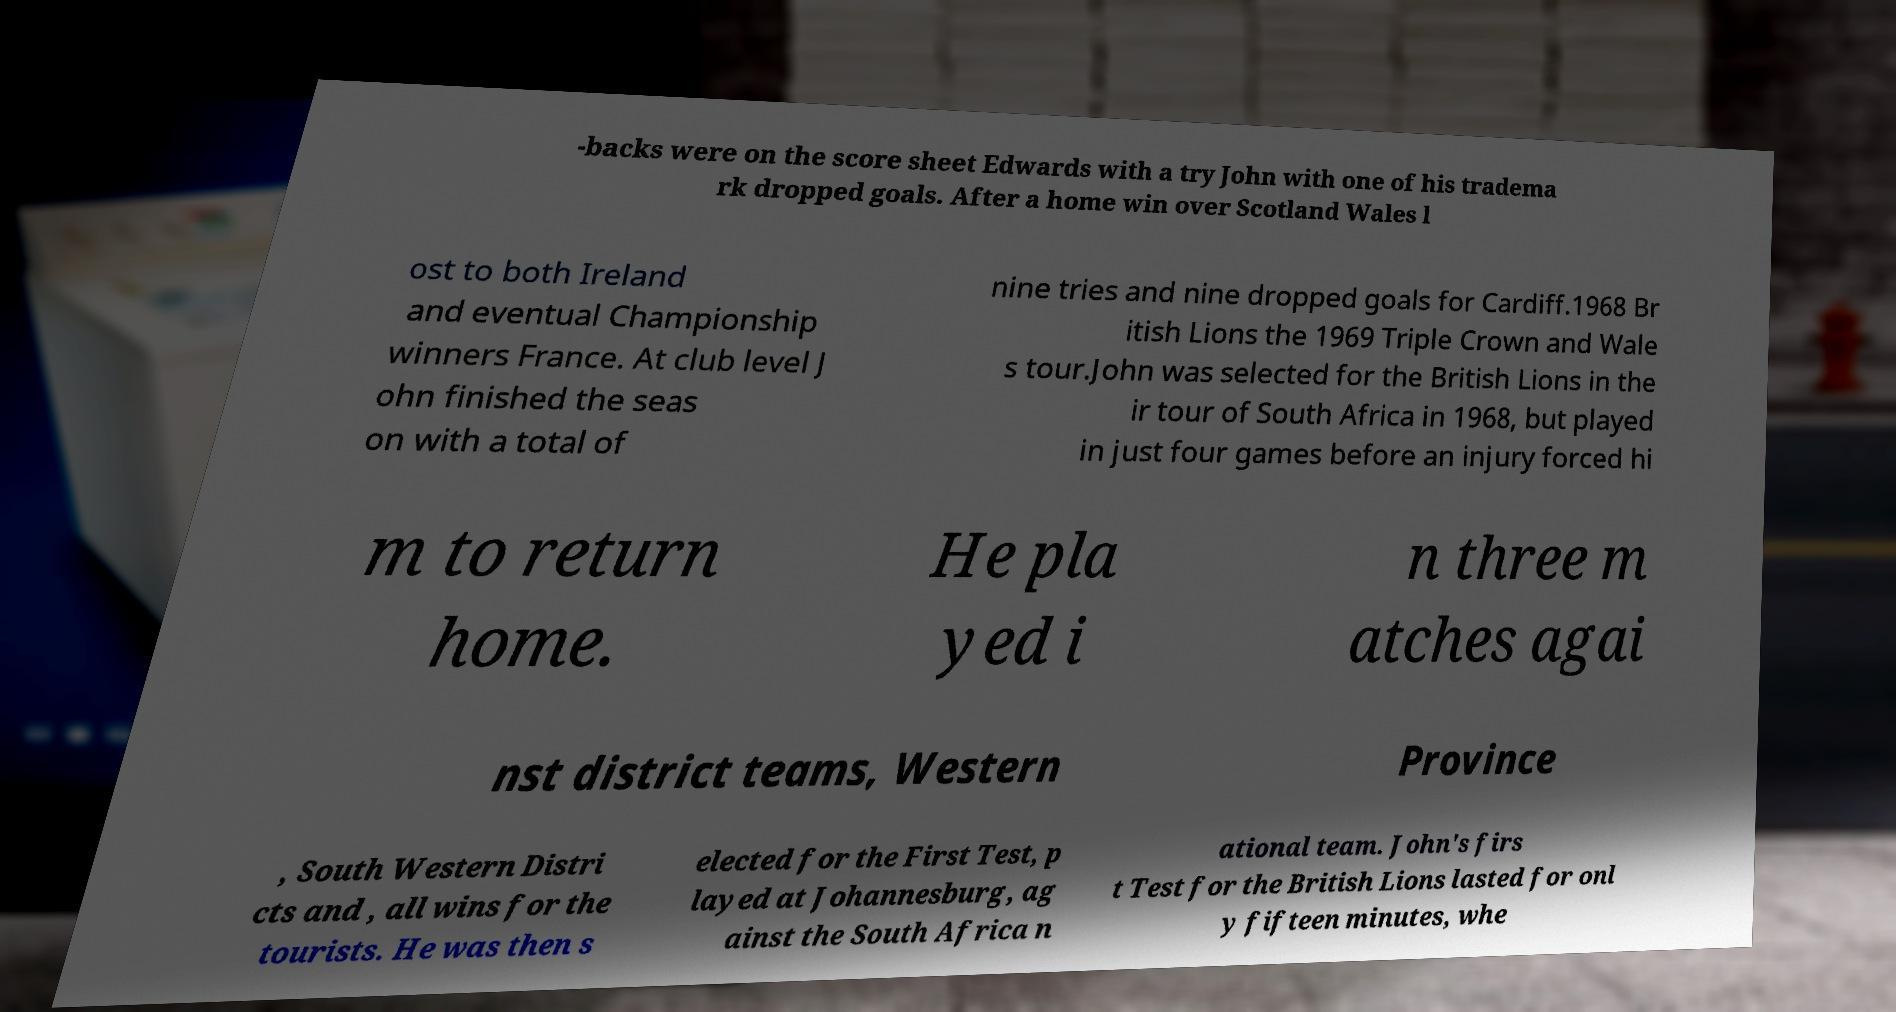Could you extract and type out the text from this image? -backs were on the score sheet Edwards with a try John with one of his tradema rk dropped goals. After a home win over Scotland Wales l ost to both Ireland and eventual Championship winners France. At club level J ohn finished the seas on with a total of nine tries and nine dropped goals for Cardiff.1968 Br itish Lions the 1969 Triple Crown and Wale s tour.John was selected for the British Lions in the ir tour of South Africa in 1968, but played in just four games before an injury forced hi m to return home. He pla yed i n three m atches agai nst district teams, Western Province , South Western Distri cts and , all wins for the tourists. He was then s elected for the First Test, p layed at Johannesburg, ag ainst the South Africa n ational team. John's firs t Test for the British Lions lasted for onl y fifteen minutes, whe 